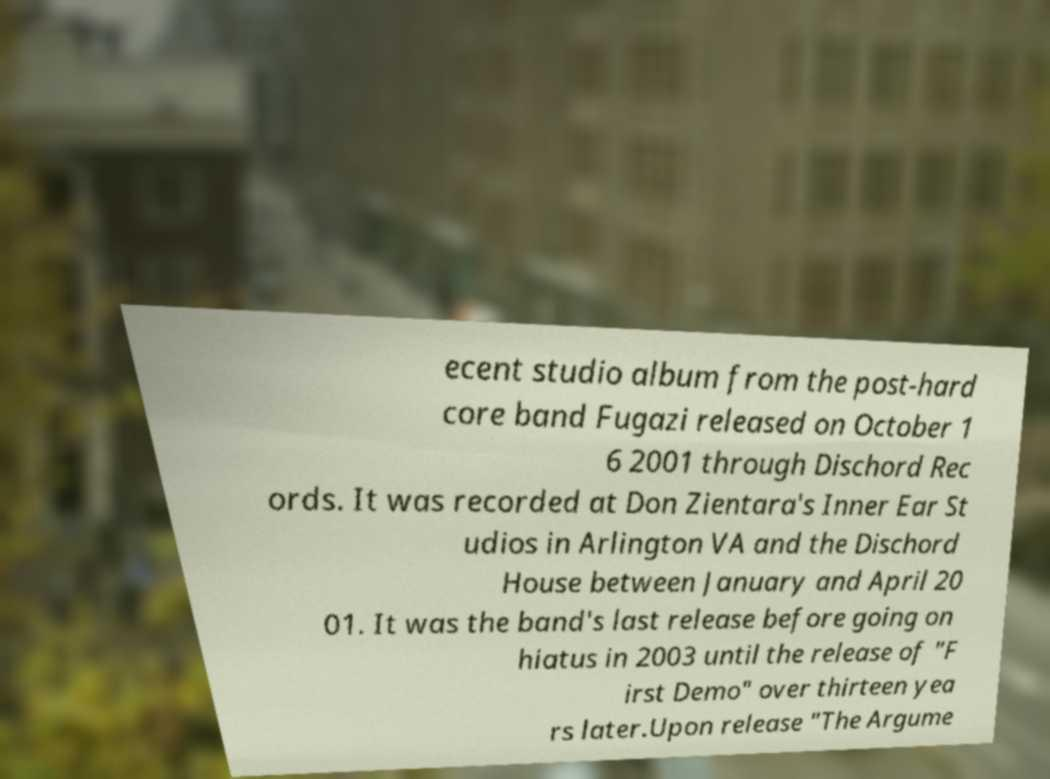There's text embedded in this image that I need extracted. Can you transcribe it verbatim? ecent studio album from the post-hard core band Fugazi released on October 1 6 2001 through Dischord Rec ords. It was recorded at Don Zientara's Inner Ear St udios in Arlington VA and the Dischord House between January and April 20 01. It was the band's last release before going on hiatus in 2003 until the release of "F irst Demo" over thirteen yea rs later.Upon release "The Argume 